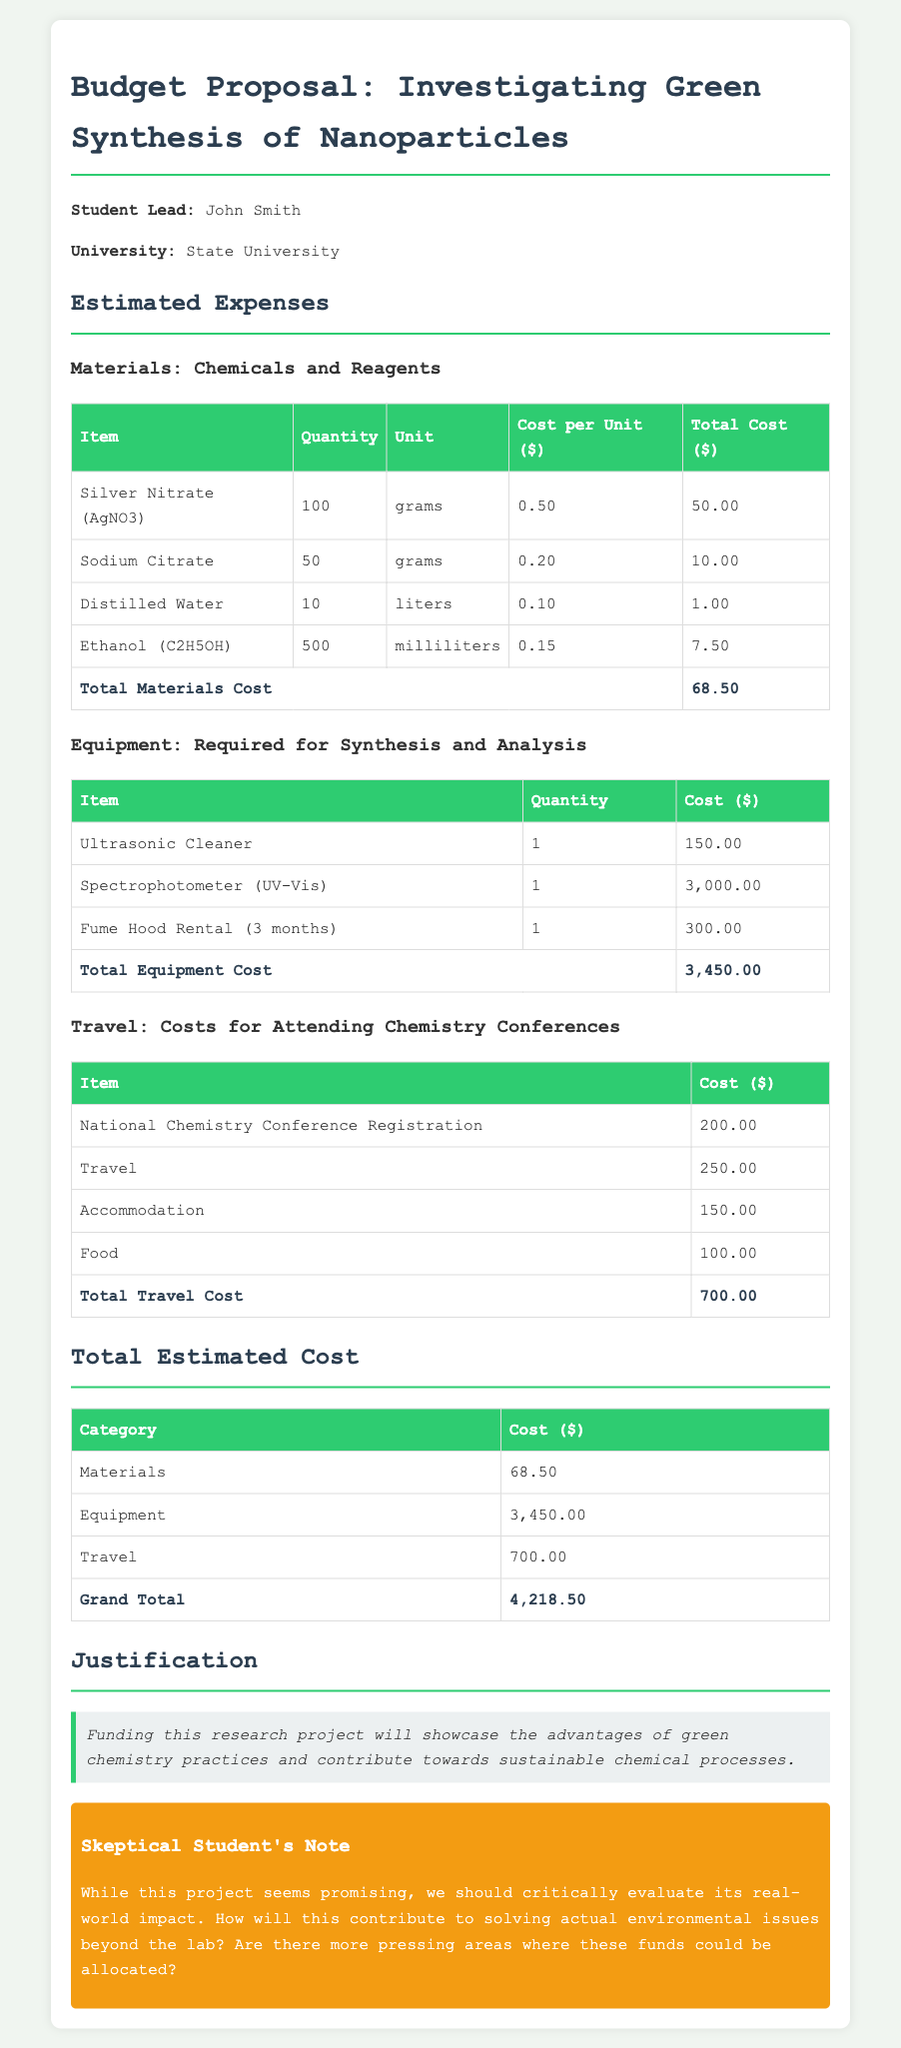what is the total materials cost? The total materials cost is provided in the materials expenses section of the document, which lists all individual expenses adding up to $68.50.
Answer: $68.50 how many grams of Silver Nitrate are included? The document states that 100 grams of Silver Nitrate (AgNO3) are listed in the materials section of the budget proposal.
Answer: 100 grams what is the cost of the Ultrasonic Cleaner? The cost of the Ultrasonic Cleaner is specifically mentioned as $150.00 in the equipment expenses.
Answer: $150.00 what are the total travel costs? The document sums up all the travel-related expenses, which amount to $700.00 in total.
Answer: $700.00 who is the student lead for the project? The document states that John Smith is the student lead for the chemistry research project.
Answer: John Smith how much is the total equipment cost? The total equipment cost is calculated by adding up all equipment expenses, which equals $3,450.00.
Answer: $3,450.00 what is the grand total of the estimated costs? The grand total is the sum of materials, equipment, and travel costs, which is presented as $4,218.50.
Answer: $4,218.50 what is the justification for the funding? The justification provided in the document mentions that funding will showcase advantages of green chemistry practices and contribute to sustainable chemical processes.
Answer: Advantages of green chemistry practices what is the cost for accommodation in travel expenses? The accommodation cost listed in the travel section of the budget is $150.00.
Answer: $150.00 how many months is the Fume Hood rental for? The Fume Hood rental is stated to cover a period of 3 months in the equipment section of the document.
Answer: 3 months 